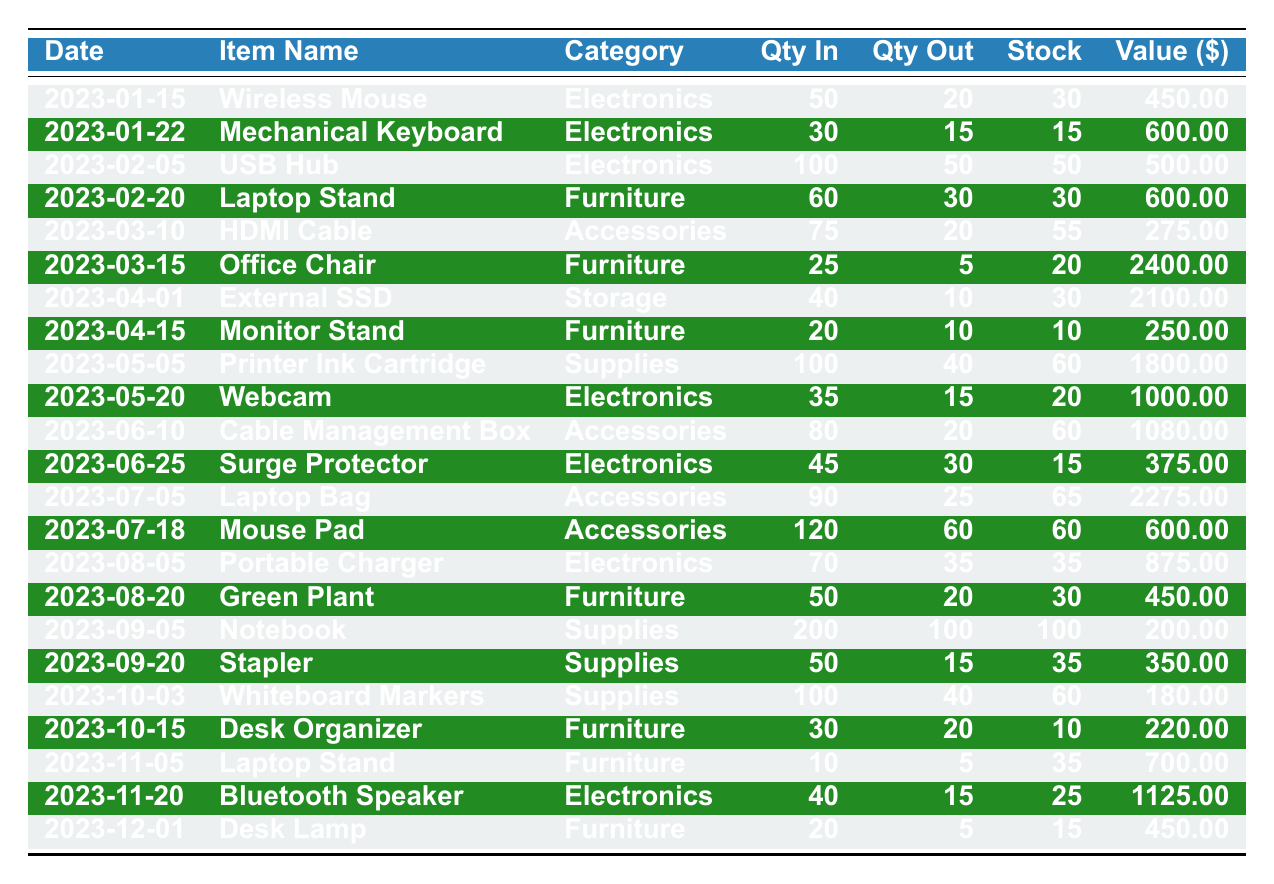What is the total quantity of "USB Hub" items received? The table shows that "USB Hub" has a Quantity In (Qty In) of 100. Therefore, the total quantity received is simply the value listed for Qty In for that item.
Answer: 100 How many "Wireless Mouse" items are currently in stock? The current stock for "Wireless Mouse" is directly mentioned in the table as 30.
Answer: 30 What is the total value of items in the "Furniture" category? The total value for each furniture item is summed: Laptop Stand ($600) + Office Chair ($2400) + Monitor Stand ($250) + Laptop Stand ($700) + Desk Organizer ($220) + Green Plant ($450) + Desk Lamp ($450). The total amounts to $600 + $2400 + $250 + $700 + $220 + $450 + $450 = $5070.
Answer: 5070 Is there a "Mechanical Keyboard" in stock? The current stock for the "Mechanical Keyboard" is 15, which is greater than 0. Therefore, it is available in stock.
Answer: Yes What item had the highest total value, and how much was it? Looking through the table, the item with the highest total value is the "Office Chair" at $2400.
Answer: Office Chair, 2400 Calculate the average unit cost of all "Electronics" category items. The unit costs for Electronics items are: Wireless Mouse ($15), Mechanical Keyboard ($40), USB Hub ($10), Webcam ($50), Surge Protector ($25), Portable Charger ($25), and Bluetooth Speaker ($45). The average is calculated as: (15 + 40 + 10 + 50 + 25 + 25 + 45) / 7 = 210 / 7 = 30.
Answer: 30 How many items had a quantity out of more than 30? The items with a "Quantity Out" (Qty Out) greater than 30 are: Mouse Pad (60), USB Hub (50), Printer Ink Cartridge (40), Webcam (35), Surge Protector (30), and Laptop Stand (40). This totals to 6 items.
Answer: 6 What is the total quantity in for the "Accessories" category? The Qty In for Accessories are: HDMI Cable (75), Cable Management Box (80), Laptop Bag (90), Mouse Pad (120). The total quantity in is 75 + 80 + 90 + 120 = 365.
Answer: 365 Which item had the least quantity in and what was it? The least quantity in is for "Desk Organizer", which had a Qty In of 30.
Answer: Desk Organizer, 30 Is the "External SSD" item available for stock? The current stock for "External SSD" is 30, so it is available.
Answer: Yes 